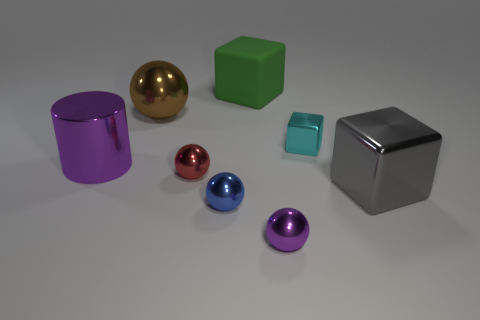Add 2 green balls. How many objects exist? 10 Subtract all blocks. How many objects are left? 5 Add 5 gray metallic objects. How many gray metallic objects exist? 6 Subtract 0 red cylinders. How many objects are left? 8 Subtract all green rubber blocks. Subtract all small metal objects. How many objects are left? 3 Add 7 large purple cylinders. How many large purple cylinders are left? 8 